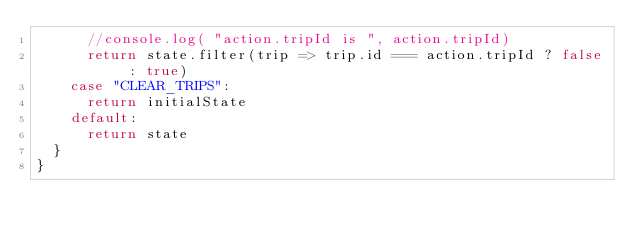<code> <loc_0><loc_0><loc_500><loc_500><_JavaScript_>      //console.log( "action.tripId is ", action.tripId)
      return state.filter(trip => trip.id === action.tripId ? false : true)
    case "CLEAR_TRIPS":
      return initialState
    default:
      return state
  }
}</code> 